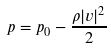<formula> <loc_0><loc_0><loc_500><loc_500>p = p _ { 0 } - \frac { \rho | v | ^ { 2 } } { 2 }</formula> 